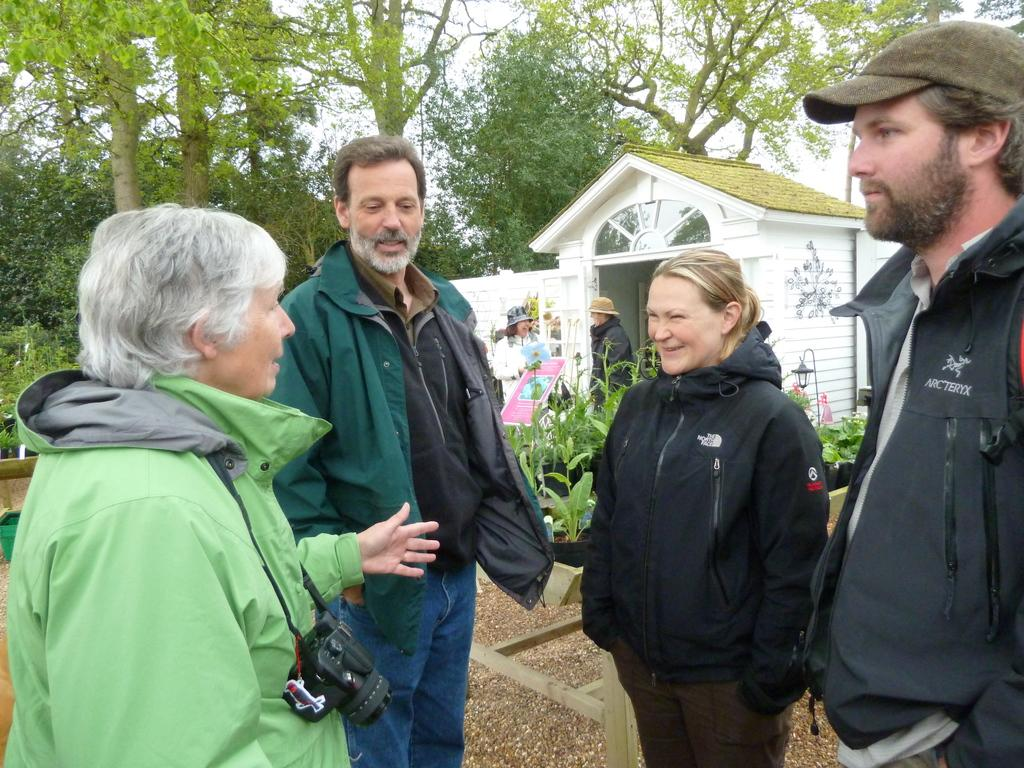What can be seen in the sky in the image? The sky is visible in the image. What type of natural elements are present in the image? There are trees and plants in the image. What type of man-made structures can be seen in the image? There is at least one building and a street light in the image. What are the people in the image doing? There are people standing on the ground in the image. What additional objects can be seen in the image? There is an information board and a camera in the image. What type of gun is being used by the person in the image? There is no person using a gun in the image. What type of pot is being used to cook food in the image? There is no pot or cooking activity in the image. 